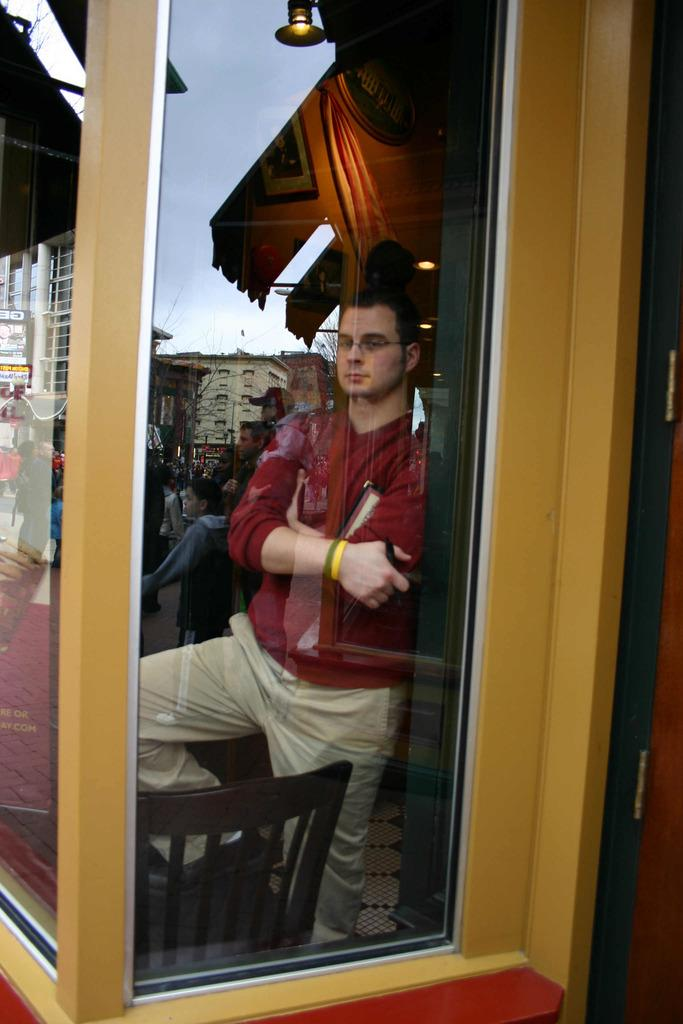Who is present in the image? There is a man in the image. What is the man standing beside? The man is standing beside a glass wall. Are there any other structures or objects in the image? Yes, there is a wooden pillar in the image. What type of sock is the man wearing in the image? There is no sock visible in the image, as the man is not wearing any footwear. 